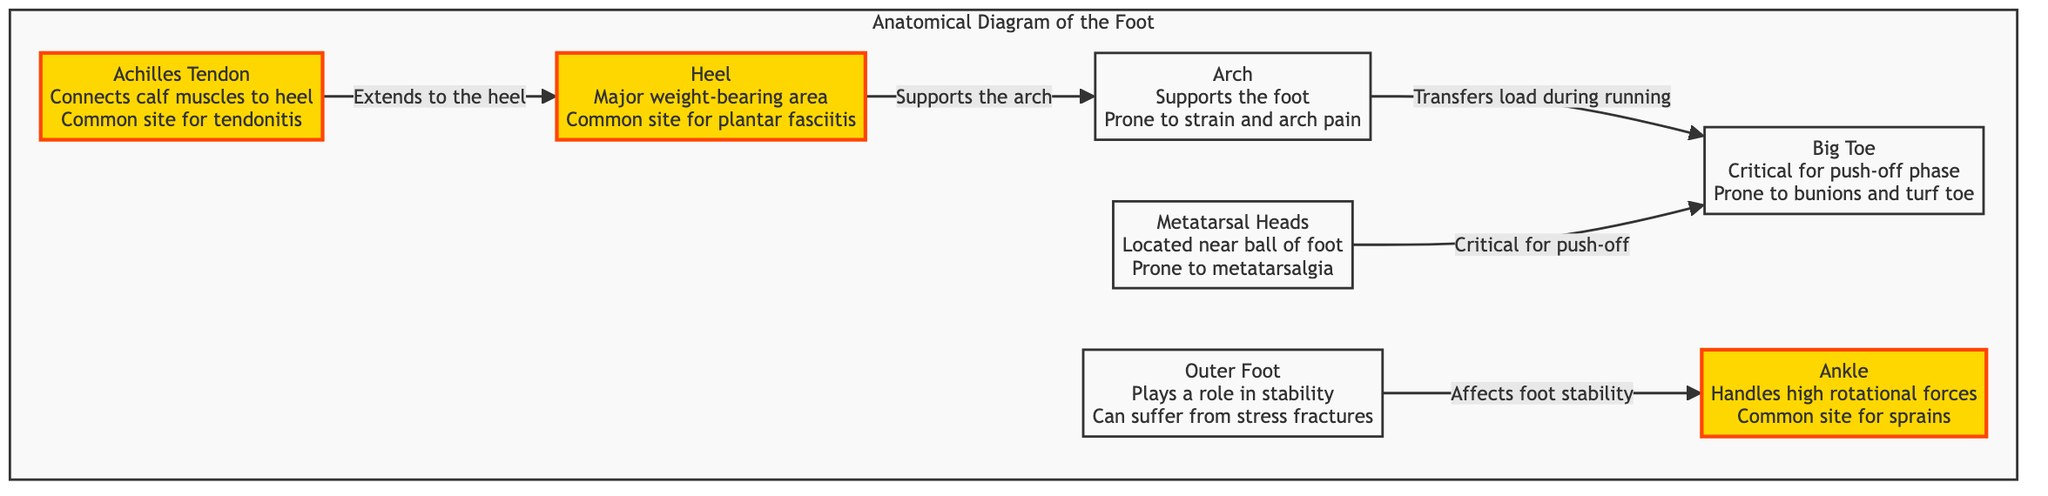What is the major weight-bearing area of the foot? The diagram identifies the "Heel" as the major weight-bearing area, given that it directly describes that characteristic.
Answer: Heel Which area is prone to strain and arch pain? The diagram explicitly states that the "Arch" supports the foot and is also prone to strain and arch pain.
Answer: Arch What connects the calf muscles to the heel? According to the diagram, the "Achilles Tendon" connects the calf muscles to the heel, as indicated in the description of that node.
Answer: Achilles Tendon How many injury sites are highlighted in the diagram? The diagram has a total of three highlighted injury sites: "Heel," "Achilles Tendon," and "Ankle," which can be counted directly from the highlighted nodes.
Answer: 3 What role does the outer foot play in stability? The diagram mentions that the "Outer Foot" affects foot stability, indicating its role in providing balance when running.
Answer: Stability Which area is critical for the push-off phase? The "Big Toe" is specifically noted as critical for the push-off phase in the running motion, as per the information presented in the diagram.
Answer: Big Toe What is the relationship between the metatarsal heads and the big toe? The diagram shows that the "Metatarsal Heads" are located near the ball of the foot and are critical for the push-off, which connects them to the "Big Toe."
Answer: Critical for push-off Which injury site handles high rotational forces? The "Ankle" is stated as the site that handles high rotational forces, making it susceptible to common sprains.
Answer: Ankle What pathway does load transfer take during running from the arch? The diagram indicates that the load transfers from the "Arch" to the "Big Toe" during running, illustrating the flow from the supporting area to the push-off area.
Answer: Arch to Big Toe 